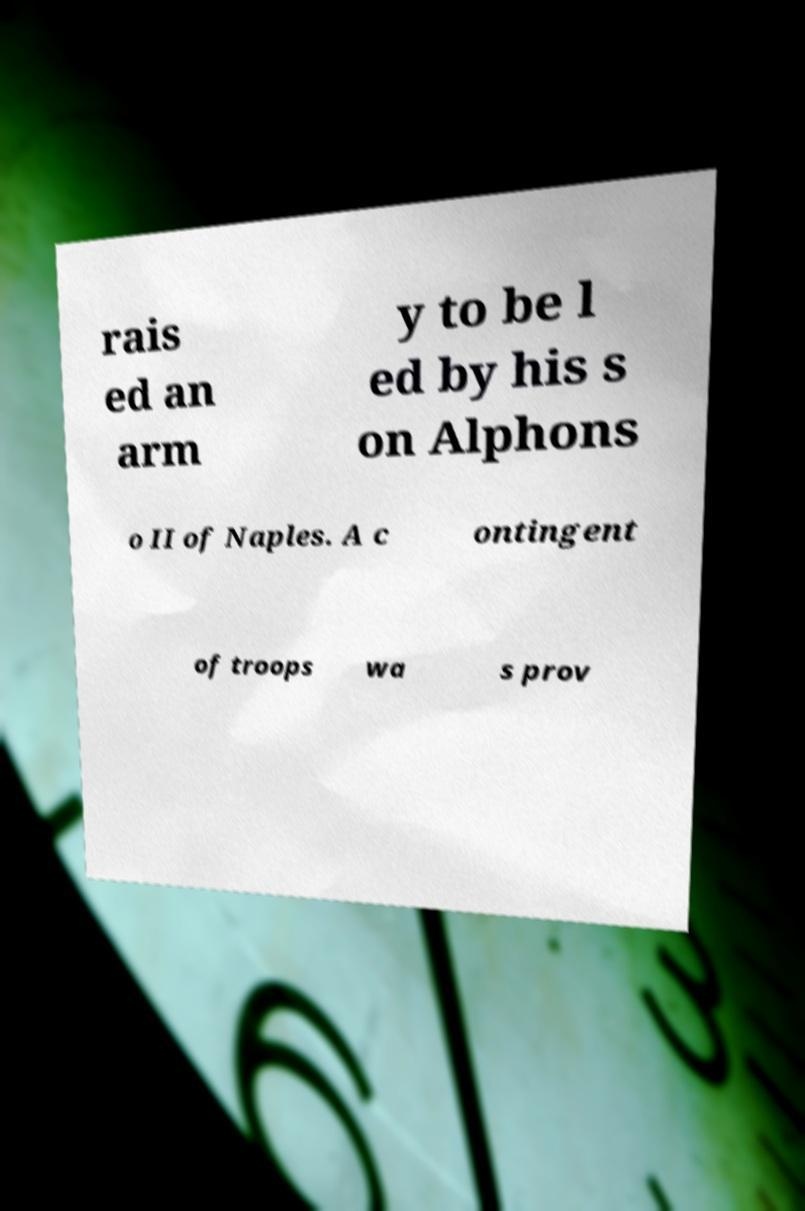Can you read and provide the text displayed in the image?This photo seems to have some interesting text. Can you extract and type it out for me? rais ed an arm y to be l ed by his s on Alphons o II of Naples. A c ontingent of troops wa s prov 